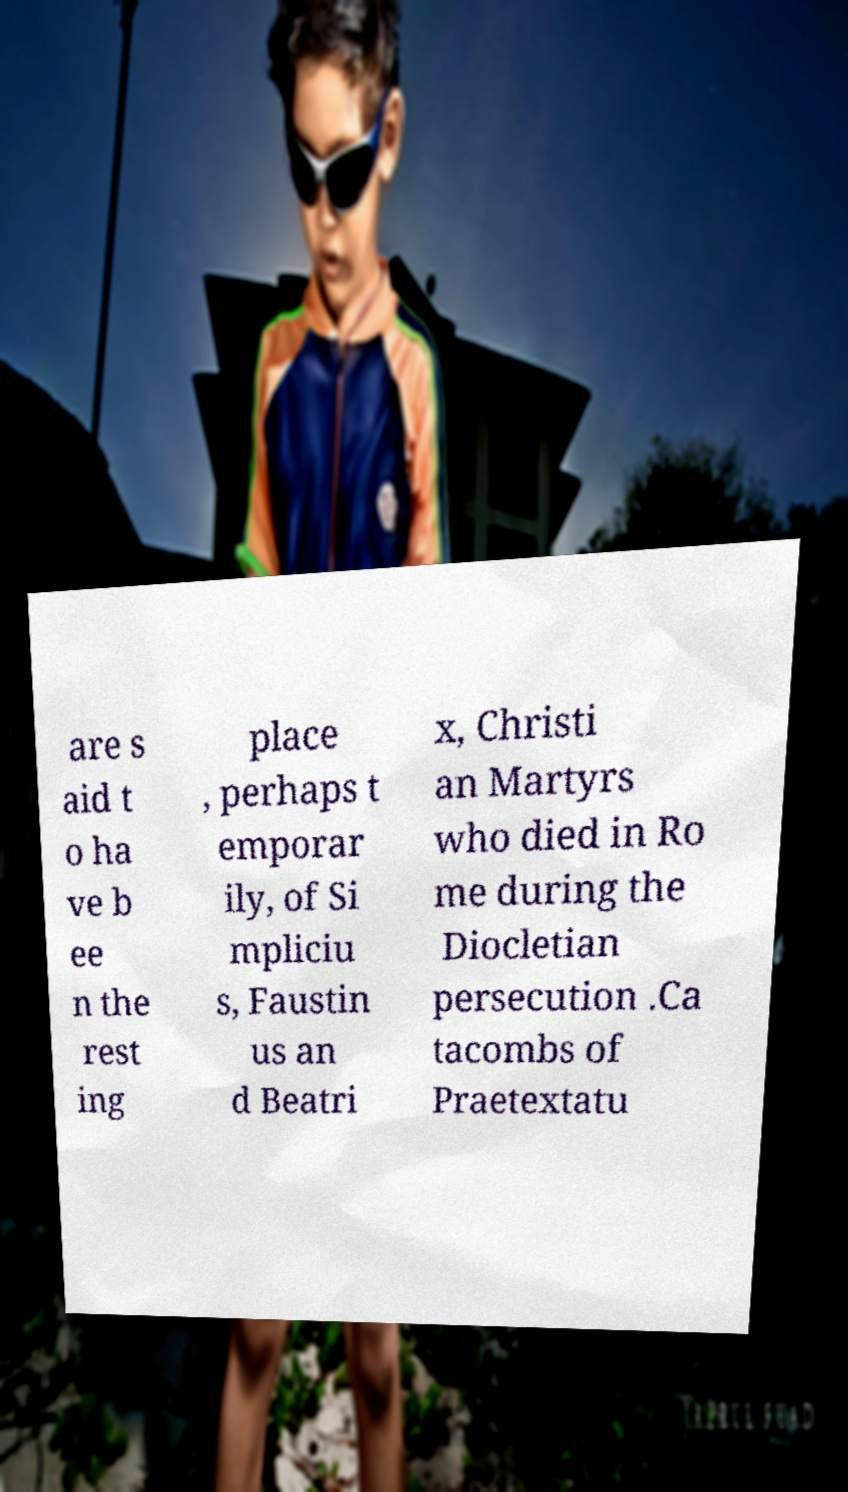Please read and relay the text visible in this image. What does it say? are s aid t o ha ve b ee n the rest ing place , perhaps t emporar ily, of Si mpliciu s, Faustin us an d Beatri x, Christi an Martyrs who died in Ro me during the Diocletian persecution .Ca tacombs of Praetextatu 